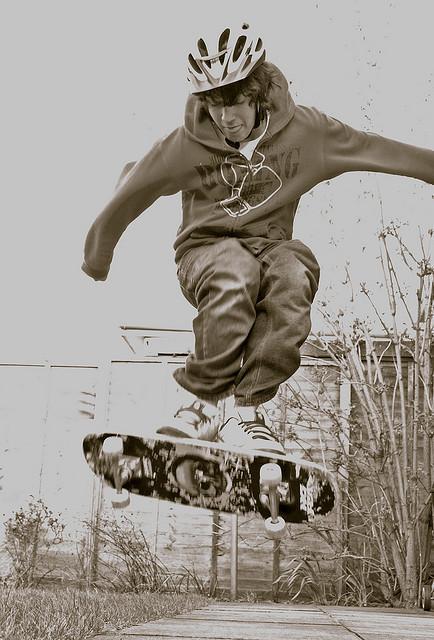How many orange cars are there in the picture?
Give a very brief answer. 0. 